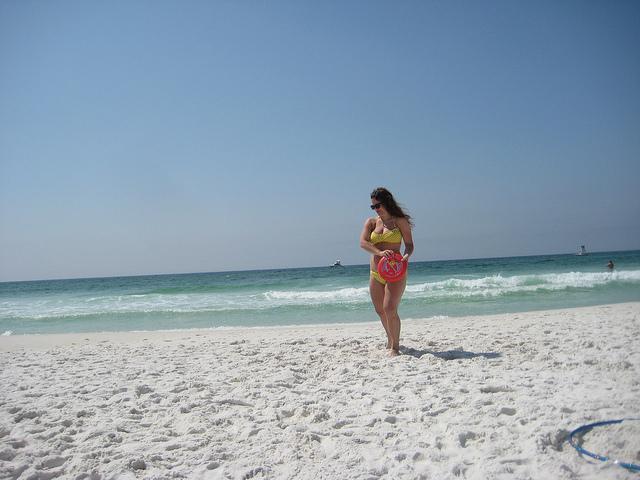How many people are in the water?
Give a very brief answer. 1. How many people are walking on the beach?
Give a very brief answer. 1. How many oxygen tubes is the man in the bed wearing?
Give a very brief answer. 0. 